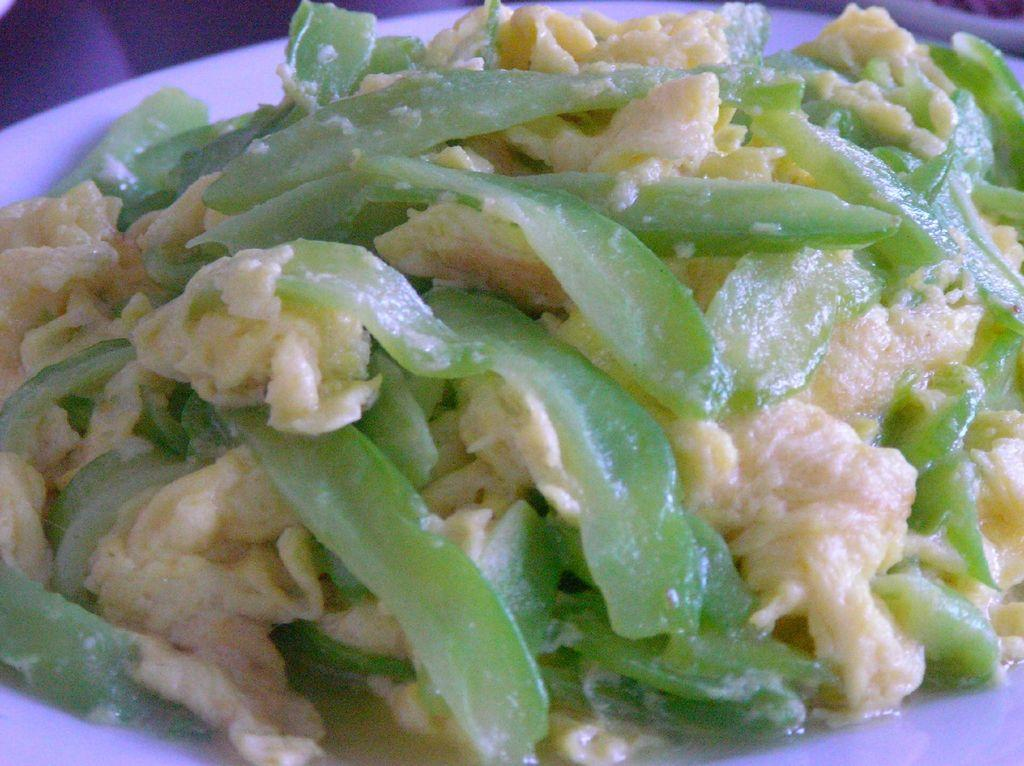What is on the plate in the image? There are food items on a plate. What color is the plate? The plate is white. Can you tell me how many buttons are on the plate in the image? There are no buttons present on the plate in the image; it contains food items. Is there a stage visible in the image? There is no stage present in the image; it only shows a plate with food items. 